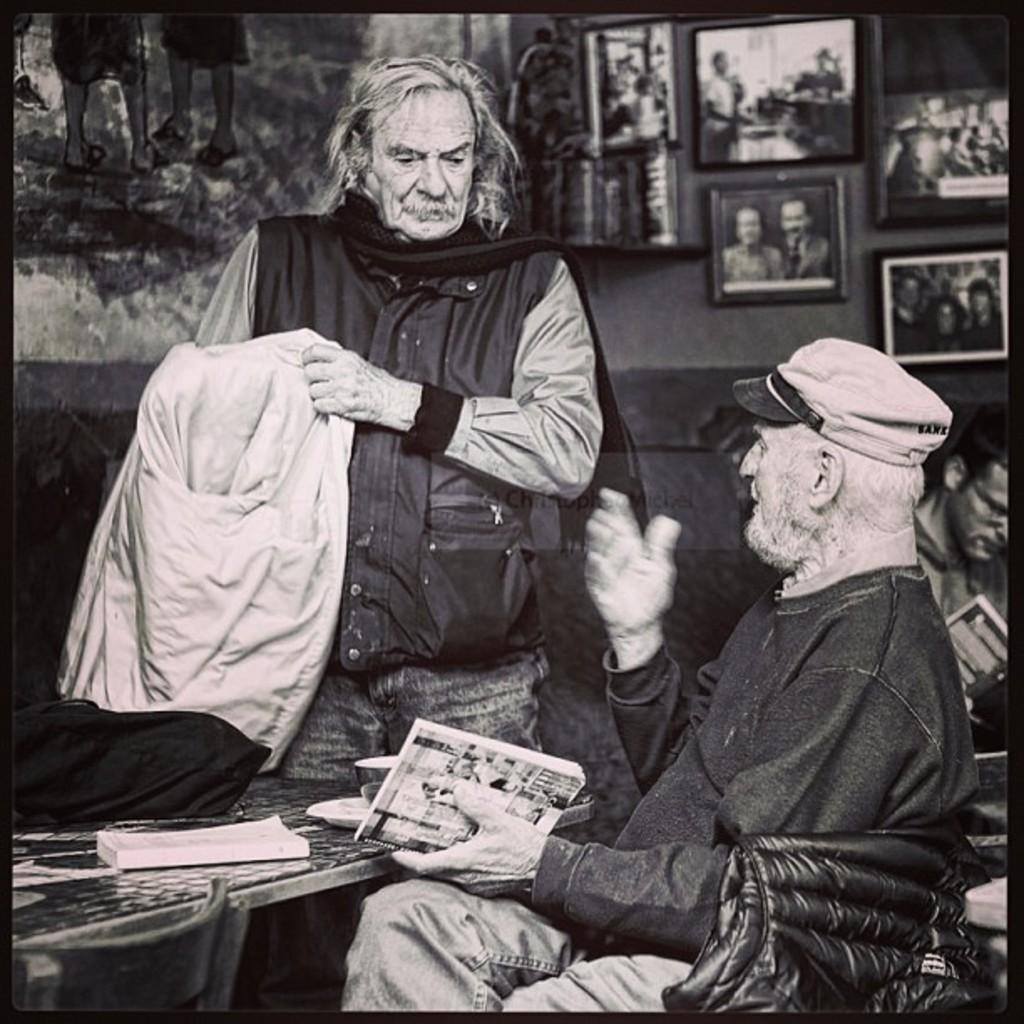How many people are present in the image? There are two people in the image, one standing and one sitting. What objects can be seen in the image besides the people? There are books and photo frames on the wall visible in the image. What might the person sitting be doing? The person sitting might be reading or studying, given the presence of books in the image. What is the purpose of the photo frames on the wall? The photo frames on the wall might be used for displaying personal or family photos. What type of fruit is being represented in the aftermath of the image? There is no fruit present in the image, nor is there any indication of an aftermath. 